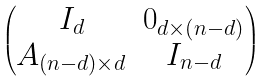<formula> <loc_0><loc_0><loc_500><loc_500>\begin{pmatrix} I _ { d } & 0 _ { d \times ( n - d ) } \\ A _ { ( n - d ) \times d } & I _ { n - d } \end{pmatrix}</formula> 